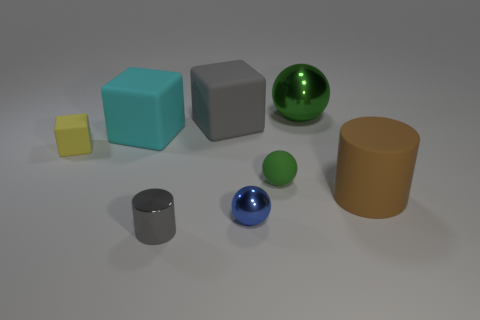Add 1 brown rubber blocks. How many objects exist? 9 Subtract all cubes. How many objects are left? 5 Add 1 small red matte balls. How many small red matte balls exist? 1 Subtract 1 brown cylinders. How many objects are left? 7 Subtract all tiny green metal things. Subtract all small cylinders. How many objects are left? 7 Add 8 tiny blue objects. How many tiny blue objects are left? 9 